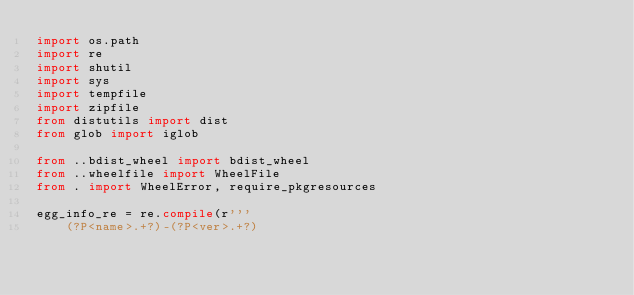<code> <loc_0><loc_0><loc_500><loc_500><_Python_>import os.path
import re
import shutil
import sys
import tempfile
import zipfile
from distutils import dist
from glob import iglob

from ..bdist_wheel import bdist_wheel
from ..wheelfile import WheelFile
from . import WheelError, require_pkgresources

egg_info_re = re.compile(r'''
    (?P<name>.+?)-(?P<ver>.+?)</code> 